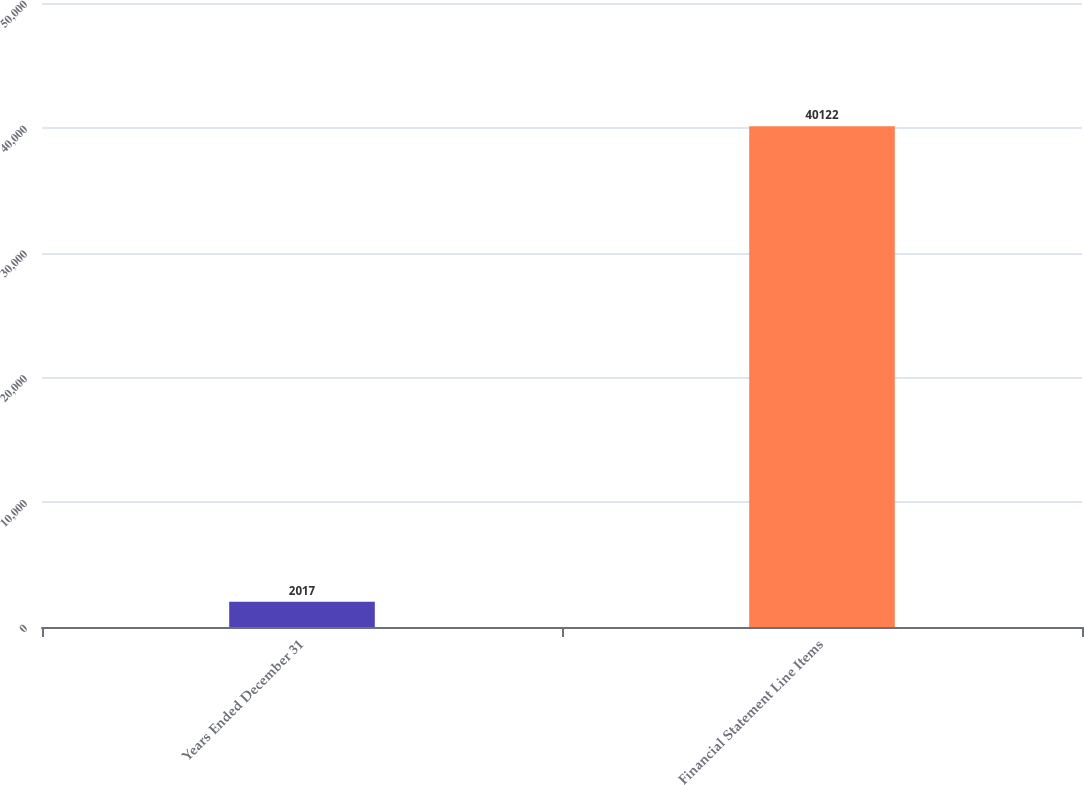<chart> <loc_0><loc_0><loc_500><loc_500><bar_chart><fcel>Years Ended December 31<fcel>Financial Statement Line Items<nl><fcel>2017<fcel>40122<nl></chart> 